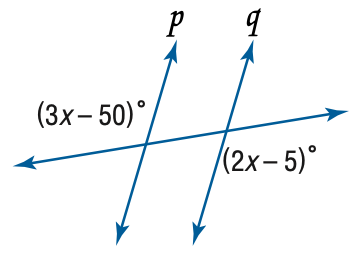Answer the mathemtical geometry problem and directly provide the correct option letter.
Question: Find x so that p \parallel q.
Choices: A: 11 B: 40 C: 45 D: 55 C 